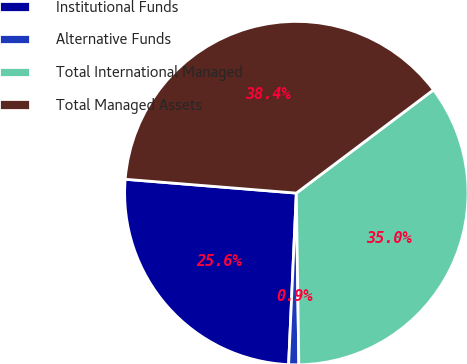<chart> <loc_0><loc_0><loc_500><loc_500><pie_chart><fcel>Institutional Funds<fcel>Alternative Funds<fcel>Total International Managed<fcel>Total Managed Assets<nl><fcel>25.57%<fcel>0.95%<fcel>35.04%<fcel>38.45%<nl></chart> 